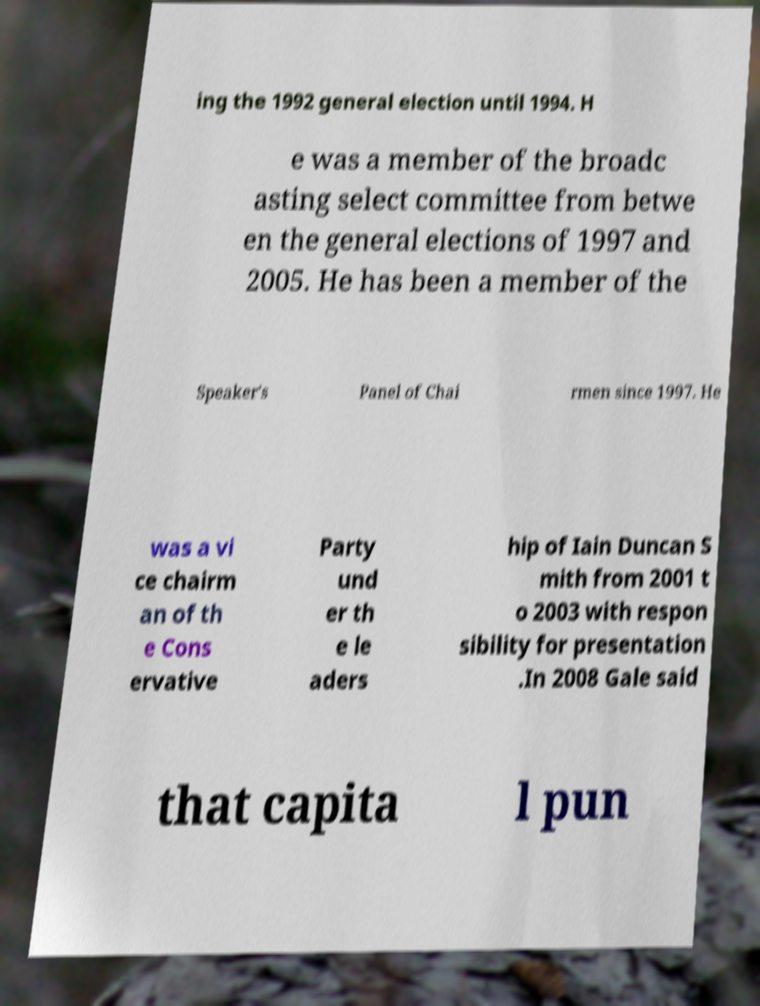I need the written content from this picture converted into text. Can you do that? ing the 1992 general election until 1994. H e was a member of the broadc asting select committee from betwe en the general elections of 1997 and 2005. He has been a member of the Speaker's Panel of Chai rmen since 1997. He was a vi ce chairm an of th e Cons ervative Party und er th e le aders hip of Iain Duncan S mith from 2001 t o 2003 with respon sibility for presentation .In 2008 Gale said that capita l pun 